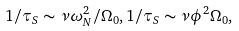<formula> <loc_0><loc_0><loc_500><loc_500>1 / \tau _ { S } \sim \nu \omega _ { N } ^ { 2 } / \Omega _ { 0 } , 1 / \tau _ { S } \sim \nu \phi ^ { 2 } \Omega _ { 0 } ,</formula> 